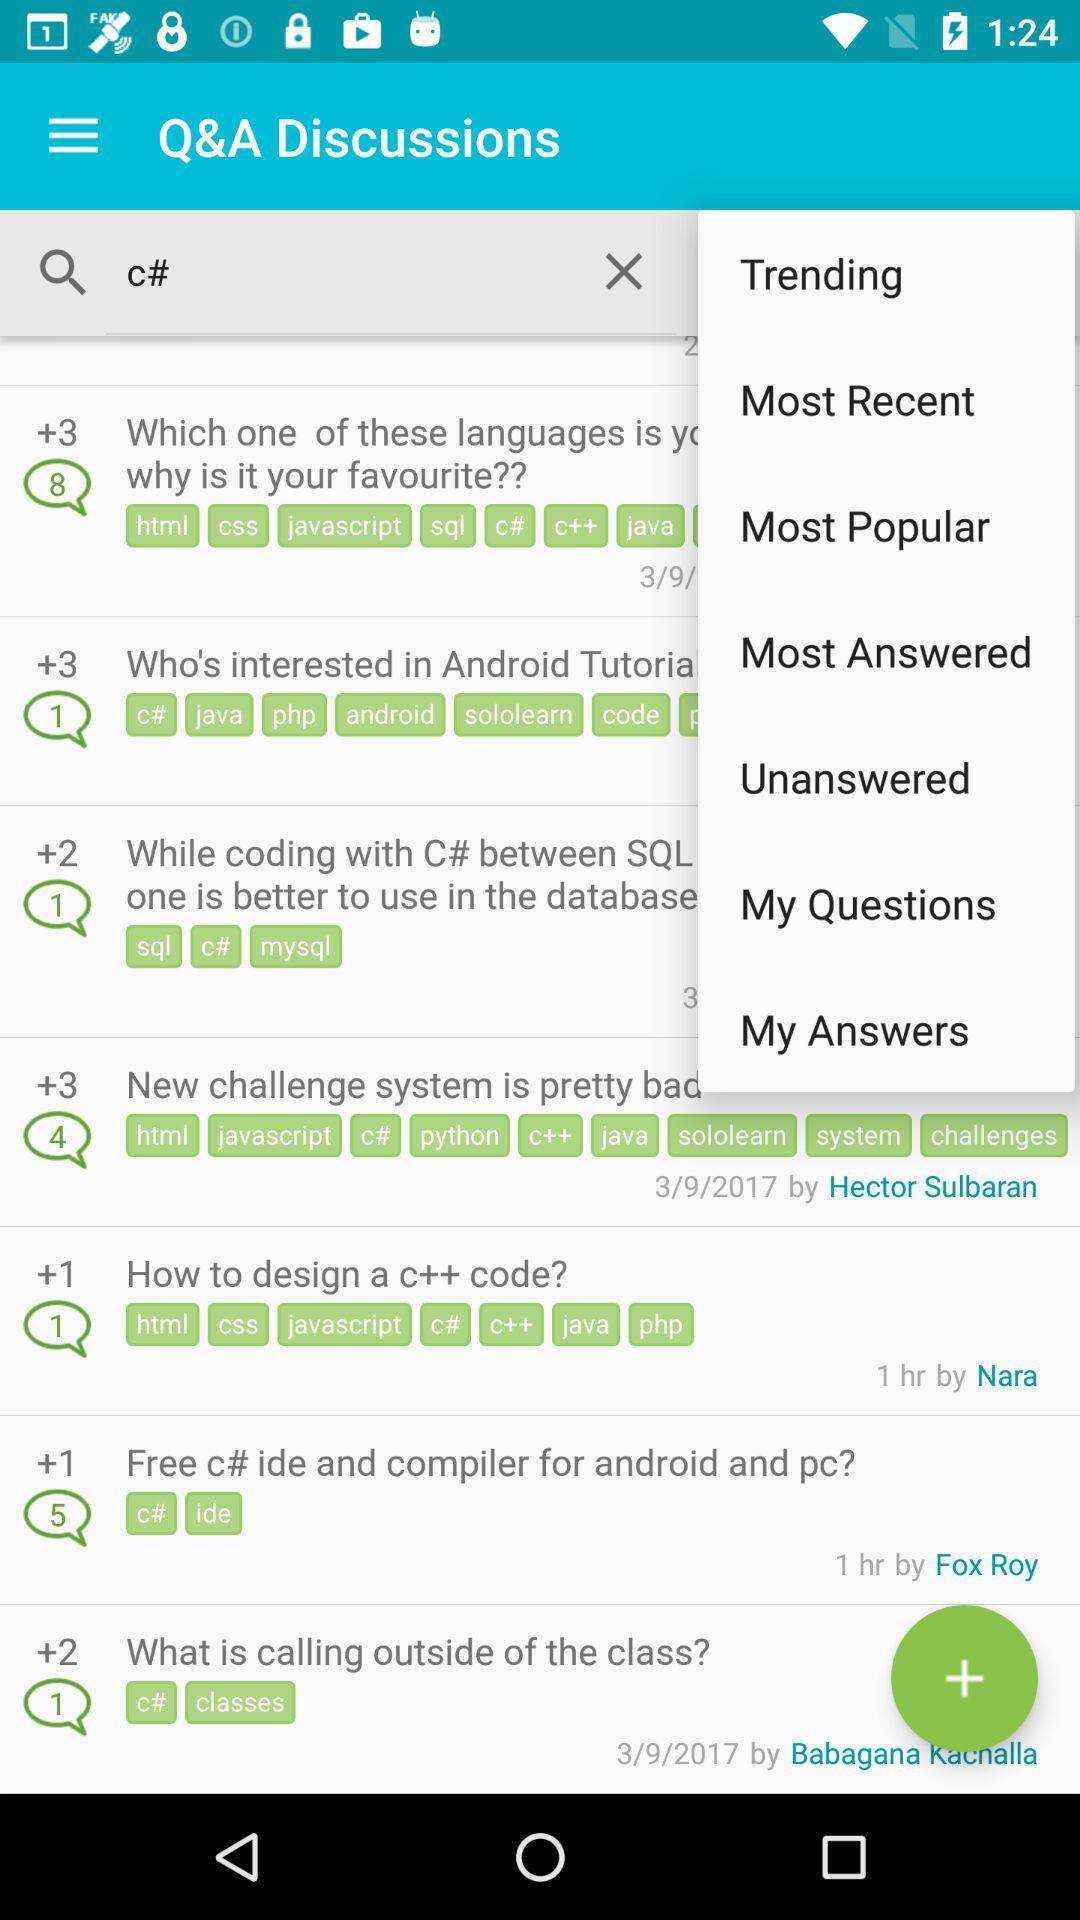What's the person name who posted "How to design a c++ code?"? The person name is Nara. 